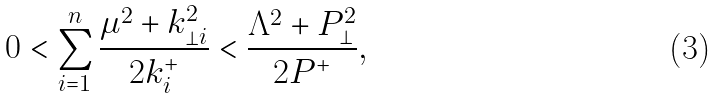<formula> <loc_0><loc_0><loc_500><loc_500>0 < \sum _ { i = 1 } ^ { n } \frac { \mu ^ { 2 } + { k } _ { \perp i } ^ { 2 } } { 2 k _ { i } ^ { + } } < \frac { \Lambda ^ { 2 } + { P } _ { \perp } ^ { 2 } } { 2 P ^ { + } } ,</formula> 